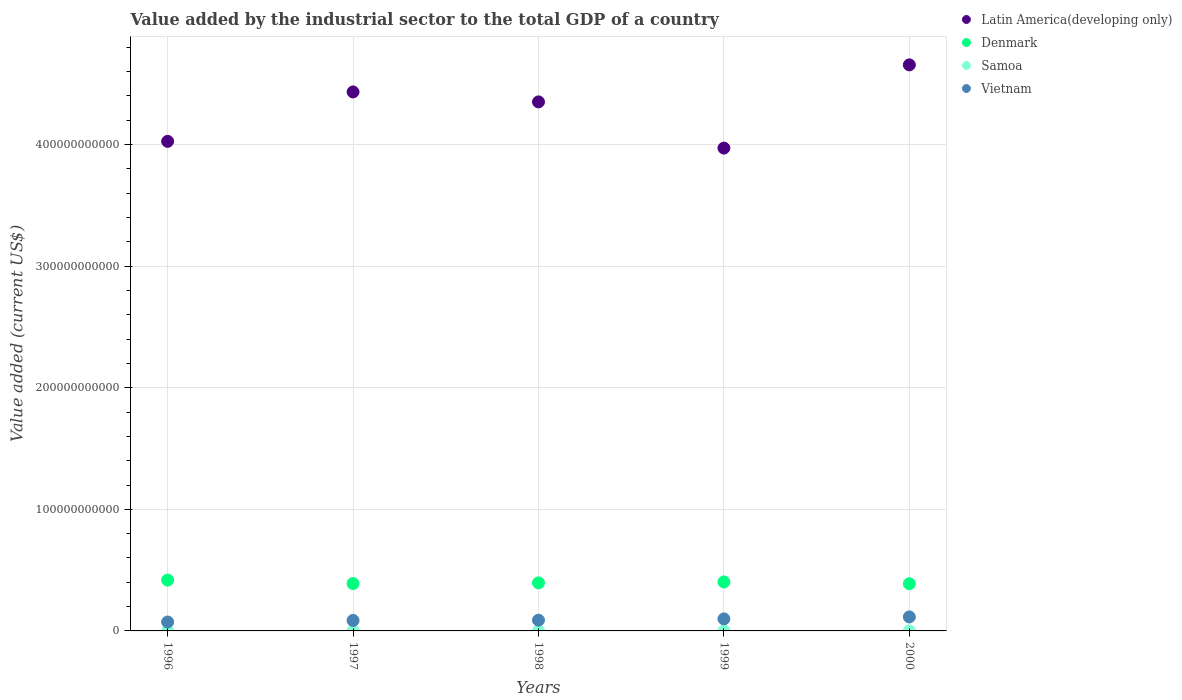What is the value added by the industrial sector to the total GDP in Latin America(developing only) in 1996?
Offer a very short reply. 4.03e+11. Across all years, what is the maximum value added by the industrial sector to the total GDP in Denmark?
Ensure brevity in your answer.  4.18e+1. Across all years, what is the minimum value added by the industrial sector to the total GDP in Samoa?
Keep it short and to the point. 6.00e+07. In which year was the value added by the industrial sector to the total GDP in Denmark minimum?
Keep it short and to the point. 2000. What is the total value added by the industrial sector to the total GDP in Denmark in the graph?
Your answer should be very brief. 1.99e+11. What is the difference between the value added by the industrial sector to the total GDP in Vietnam in 1996 and that in 1999?
Make the answer very short. -2.56e+09. What is the difference between the value added by the industrial sector to the total GDP in Samoa in 1997 and the value added by the industrial sector to the total GDP in Latin America(developing only) in 1999?
Keep it short and to the point. -3.97e+11. What is the average value added by the industrial sector to the total GDP in Denmark per year?
Provide a succinct answer. 3.99e+1. In the year 2000, what is the difference between the value added by the industrial sector to the total GDP in Vietnam and value added by the industrial sector to the total GDP in Samoa?
Provide a short and direct response. 1.14e+1. What is the ratio of the value added by the industrial sector to the total GDP in Vietnam in 1996 to that in 1998?
Keep it short and to the point. 0.83. Is the value added by the industrial sector to the total GDP in Samoa in 1999 less than that in 2000?
Keep it short and to the point. Yes. Is the difference between the value added by the industrial sector to the total GDP in Vietnam in 1998 and 1999 greater than the difference between the value added by the industrial sector to the total GDP in Samoa in 1998 and 1999?
Your response must be concise. No. What is the difference between the highest and the second highest value added by the industrial sector to the total GDP in Latin America(developing only)?
Offer a very short reply. 2.22e+1. What is the difference between the highest and the lowest value added by the industrial sector to the total GDP in Denmark?
Provide a short and direct response. 2.99e+09. In how many years, is the value added by the industrial sector to the total GDP in Vietnam greater than the average value added by the industrial sector to the total GDP in Vietnam taken over all years?
Your answer should be very brief. 2. Is the value added by the industrial sector to the total GDP in Vietnam strictly greater than the value added by the industrial sector to the total GDP in Latin America(developing only) over the years?
Offer a terse response. No. How many years are there in the graph?
Your answer should be very brief. 5. What is the difference between two consecutive major ticks on the Y-axis?
Ensure brevity in your answer.  1.00e+11. Does the graph contain grids?
Ensure brevity in your answer.  Yes. What is the title of the graph?
Give a very brief answer. Value added by the industrial sector to the total GDP of a country. What is the label or title of the X-axis?
Keep it short and to the point. Years. What is the label or title of the Y-axis?
Offer a very short reply. Value added (current US$). What is the Value added (current US$) of Latin America(developing only) in 1996?
Give a very brief answer. 4.03e+11. What is the Value added (current US$) in Denmark in 1996?
Provide a succinct answer. 4.18e+1. What is the Value added (current US$) of Samoa in 1996?
Make the answer very short. 6.72e+07. What is the Value added (current US$) of Vietnam in 1996?
Keep it short and to the point. 7.33e+09. What is the Value added (current US$) in Latin America(developing only) in 1997?
Provide a succinct answer. 4.43e+11. What is the Value added (current US$) of Denmark in 1997?
Your answer should be very brief. 3.90e+1. What is the Value added (current US$) in Samoa in 1997?
Provide a short and direct response. 7.11e+07. What is the Value added (current US$) of Vietnam in 1997?
Your answer should be very brief. 8.61e+09. What is the Value added (current US$) in Latin America(developing only) in 1998?
Make the answer very short. 4.35e+11. What is the Value added (current US$) in Denmark in 1998?
Give a very brief answer. 3.95e+1. What is the Value added (current US$) in Samoa in 1998?
Offer a very short reply. 6.24e+07. What is the Value added (current US$) of Vietnam in 1998?
Offer a very short reply. 8.84e+09. What is the Value added (current US$) in Latin America(developing only) in 1999?
Offer a very short reply. 3.97e+11. What is the Value added (current US$) in Denmark in 1999?
Provide a short and direct response. 4.03e+1. What is the Value added (current US$) of Samoa in 1999?
Provide a short and direct response. 6.00e+07. What is the Value added (current US$) of Vietnam in 1999?
Ensure brevity in your answer.  9.89e+09. What is the Value added (current US$) of Latin America(developing only) in 2000?
Your answer should be compact. 4.66e+11. What is the Value added (current US$) of Denmark in 2000?
Your answer should be compact. 3.88e+1. What is the Value added (current US$) of Samoa in 2000?
Your answer should be compact. 6.65e+07. What is the Value added (current US$) in Vietnam in 2000?
Provide a short and direct response. 1.15e+1. Across all years, what is the maximum Value added (current US$) in Latin America(developing only)?
Provide a succinct answer. 4.66e+11. Across all years, what is the maximum Value added (current US$) in Denmark?
Give a very brief answer. 4.18e+1. Across all years, what is the maximum Value added (current US$) in Samoa?
Your response must be concise. 7.11e+07. Across all years, what is the maximum Value added (current US$) of Vietnam?
Provide a short and direct response. 1.15e+1. Across all years, what is the minimum Value added (current US$) in Latin America(developing only)?
Keep it short and to the point. 3.97e+11. Across all years, what is the minimum Value added (current US$) of Denmark?
Offer a terse response. 3.88e+1. Across all years, what is the minimum Value added (current US$) in Samoa?
Provide a succinct answer. 6.00e+07. Across all years, what is the minimum Value added (current US$) in Vietnam?
Provide a succinct answer. 7.33e+09. What is the total Value added (current US$) in Latin America(developing only) in the graph?
Provide a short and direct response. 2.14e+12. What is the total Value added (current US$) of Denmark in the graph?
Provide a succinct answer. 1.99e+11. What is the total Value added (current US$) in Samoa in the graph?
Give a very brief answer. 3.27e+08. What is the total Value added (current US$) in Vietnam in the graph?
Your answer should be very brief. 4.62e+1. What is the difference between the Value added (current US$) in Latin America(developing only) in 1996 and that in 1997?
Offer a very short reply. -4.07e+1. What is the difference between the Value added (current US$) of Denmark in 1996 and that in 1997?
Keep it short and to the point. 2.86e+09. What is the difference between the Value added (current US$) of Samoa in 1996 and that in 1997?
Ensure brevity in your answer.  -3.86e+06. What is the difference between the Value added (current US$) of Vietnam in 1996 and that in 1997?
Your answer should be compact. -1.28e+09. What is the difference between the Value added (current US$) in Latin America(developing only) in 1996 and that in 1998?
Ensure brevity in your answer.  -3.24e+1. What is the difference between the Value added (current US$) in Denmark in 1996 and that in 1998?
Provide a short and direct response. 2.30e+09. What is the difference between the Value added (current US$) of Samoa in 1996 and that in 1998?
Your response must be concise. 4.77e+06. What is the difference between the Value added (current US$) of Vietnam in 1996 and that in 1998?
Offer a terse response. -1.51e+09. What is the difference between the Value added (current US$) in Latin America(developing only) in 1996 and that in 1999?
Your answer should be compact. 5.54e+09. What is the difference between the Value added (current US$) of Denmark in 1996 and that in 1999?
Give a very brief answer. 1.53e+09. What is the difference between the Value added (current US$) in Samoa in 1996 and that in 1999?
Offer a terse response. 7.21e+06. What is the difference between the Value added (current US$) of Vietnam in 1996 and that in 1999?
Provide a succinct answer. -2.56e+09. What is the difference between the Value added (current US$) of Latin America(developing only) in 1996 and that in 2000?
Your answer should be compact. -6.29e+1. What is the difference between the Value added (current US$) in Denmark in 1996 and that in 2000?
Your response must be concise. 2.99e+09. What is the difference between the Value added (current US$) in Samoa in 1996 and that in 2000?
Make the answer very short. 7.45e+05. What is the difference between the Value added (current US$) in Vietnam in 1996 and that in 2000?
Ensure brevity in your answer.  -4.17e+09. What is the difference between the Value added (current US$) of Latin America(developing only) in 1997 and that in 1998?
Your answer should be very brief. 8.21e+09. What is the difference between the Value added (current US$) in Denmark in 1997 and that in 1998?
Give a very brief answer. -5.51e+08. What is the difference between the Value added (current US$) in Samoa in 1997 and that in 1998?
Offer a terse response. 8.63e+06. What is the difference between the Value added (current US$) in Vietnam in 1997 and that in 1998?
Offer a very short reply. -2.31e+08. What is the difference between the Value added (current US$) in Latin America(developing only) in 1997 and that in 1999?
Provide a short and direct response. 4.62e+1. What is the difference between the Value added (current US$) in Denmark in 1997 and that in 1999?
Offer a terse response. -1.32e+09. What is the difference between the Value added (current US$) in Samoa in 1997 and that in 1999?
Make the answer very short. 1.11e+07. What is the difference between the Value added (current US$) in Vietnam in 1997 and that in 1999?
Make the answer very short. -1.28e+09. What is the difference between the Value added (current US$) of Latin America(developing only) in 1997 and that in 2000?
Give a very brief answer. -2.22e+1. What is the difference between the Value added (current US$) in Denmark in 1997 and that in 2000?
Your answer should be compact. 1.36e+08. What is the difference between the Value added (current US$) in Samoa in 1997 and that in 2000?
Offer a very short reply. 4.61e+06. What is the difference between the Value added (current US$) of Vietnam in 1997 and that in 2000?
Provide a succinct answer. -2.89e+09. What is the difference between the Value added (current US$) of Latin America(developing only) in 1998 and that in 1999?
Provide a succinct answer. 3.80e+1. What is the difference between the Value added (current US$) of Denmark in 1998 and that in 1999?
Your response must be concise. -7.73e+08. What is the difference between the Value added (current US$) in Samoa in 1998 and that in 1999?
Keep it short and to the point. 2.44e+06. What is the difference between the Value added (current US$) in Vietnam in 1998 and that in 1999?
Give a very brief answer. -1.05e+09. What is the difference between the Value added (current US$) of Latin America(developing only) in 1998 and that in 2000?
Give a very brief answer. -3.05e+1. What is the difference between the Value added (current US$) of Denmark in 1998 and that in 2000?
Offer a terse response. 6.87e+08. What is the difference between the Value added (current US$) in Samoa in 1998 and that in 2000?
Make the answer very short. -4.02e+06. What is the difference between the Value added (current US$) in Vietnam in 1998 and that in 2000?
Your response must be concise. -2.66e+09. What is the difference between the Value added (current US$) in Latin America(developing only) in 1999 and that in 2000?
Your answer should be very brief. -6.84e+1. What is the difference between the Value added (current US$) in Denmark in 1999 and that in 2000?
Ensure brevity in your answer.  1.46e+09. What is the difference between the Value added (current US$) of Samoa in 1999 and that in 2000?
Provide a succinct answer. -6.47e+06. What is the difference between the Value added (current US$) of Vietnam in 1999 and that in 2000?
Offer a terse response. -1.61e+09. What is the difference between the Value added (current US$) of Latin America(developing only) in 1996 and the Value added (current US$) of Denmark in 1997?
Provide a short and direct response. 3.64e+11. What is the difference between the Value added (current US$) in Latin America(developing only) in 1996 and the Value added (current US$) in Samoa in 1997?
Your response must be concise. 4.03e+11. What is the difference between the Value added (current US$) in Latin America(developing only) in 1996 and the Value added (current US$) in Vietnam in 1997?
Offer a very short reply. 3.94e+11. What is the difference between the Value added (current US$) of Denmark in 1996 and the Value added (current US$) of Samoa in 1997?
Your response must be concise. 4.17e+1. What is the difference between the Value added (current US$) in Denmark in 1996 and the Value added (current US$) in Vietnam in 1997?
Your response must be concise. 3.32e+1. What is the difference between the Value added (current US$) of Samoa in 1996 and the Value added (current US$) of Vietnam in 1997?
Give a very brief answer. -8.54e+09. What is the difference between the Value added (current US$) in Latin America(developing only) in 1996 and the Value added (current US$) in Denmark in 1998?
Offer a very short reply. 3.63e+11. What is the difference between the Value added (current US$) of Latin America(developing only) in 1996 and the Value added (current US$) of Samoa in 1998?
Offer a terse response. 4.03e+11. What is the difference between the Value added (current US$) in Latin America(developing only) in 1996 and the Value added (current US$) in Vietnam in 1998?
Offer a very short reply. 3.94e+11. What is the difference between the Value added (current US$) of Denmark in 1996 and the Value added (current US$) of Samoa in 1998?
Your answer should be very brief. 4.18e+1. What is the difference between the Value added (current US$) in Denmark in 1996 and the Value added (current US$) in Vietnam in 1998?
Make the answer very short. 3.30e+1. What is the difference between the Value added (current US$) of Samoa in 1996 and the Value added (current US$) of Vietnam in 1998?
Keep it short and to the point. -8.77e+09. What is the difference between the Value added (current US$) of Latin America(developing only) in 1996 and the Value added (current US$) of Denmark in 1999?
Offer a terse response. 3.62e+11. What is the difference between the Value added (current US$) in Latin America(developing only) in 1996 and the Value added (current US$) in Samoa in 1999?
Give a very brief answer. 4.03e+11. What is the difference between the Value added (current US$) of Latin America(developing only) in 1996 and the Value added (current US$) of Vietnam in 1999?
Your answer should be very brief. 3.93e+11. What is the difference between the Value added (current US$) of Denmark in 1996 and the Value added (current US$) of Samoa in 1999?
Provide a short and direct response. 4.18e+1. What is the difference between the Value added (current US$) in Denmark in 1996 and the Value added (current US$) in Vietnam in 1999?
Offer a terse response. 3.19e+1. What is the difference between the Value added (current US$) of Samoa in 1996 and the Value added (current US$) of Vietnam in 1999?
Your answer should be compact. -9.83e+09. What is the difference between the Value added (current US$) in Latin America(developing only) in 1996 and the Value added (current US$) in Denmark in 2000?
Your answer should be compact. 3.64e+11. What is the difference between the Value added (current US$) in Latin America(developing only) in 1996 and the Value added (current US$) in Samoa in 2000?
Your answer should be compact. 4.03e+11. What is the difference between the Value added (current US$) in Latin America(developing only) in 1996 and the Value added (current US$) in Vietnam in 2000?
Offer a terse response. 3.91e+11. What is the difference between the Value added (current US$) in Denmark in 1996 and the Value added (current US$) in Samoa in 2000?
Offer a very short reply. 4.18e+1. What is the difference between the Value added (current US$) of Denmark in 1996 and the Value added (current US$) of Vietnam in 2000?
Make the answer very short. 3.03e+1. What is the difference between the Value added (current US$) of Samoa in 1996 and the Value added (current US$) of Vietnam in 2000?
Keep it short and to the point. -1.14e+1. What is the difference between the Value added (current US$) of Latin America(developing only) in 1997 and the Value added (current US$) of Denmark in 1998?
Offer a very short reply. 4.04e+11. What is the difference between the Value added (current US$) in Latin America(developing only) in 1997 and the Value added (current US$) in Samoa in 1998?
Your response must be concise. 4.43e+11. What is the difference between the Value added (current US$) in Latin America(developing only) in 1997 and the Value added (current US$) in Vietnam in 1998?
Ensure brevity in your answer.  4.34e+11. What is the difference between the Value added (current US$) in Denmark in 1997 and the Value added (current US$) in Samoa in 1998?
Offer a terse response. 3.89e+1. What is the difference between the Value added (current US$) in Denmark in 1997 and the Value added (current US$) in Vietnam in 1998?
Make the answer very short. 3.01e+1. What is the difference between the Value added (current US$) of Samoa in 1997 and the Value added (current US$) of Vietnam in 1998?
Give a very brief answer. -8.77e+09. What is the difference between the Value added (current US$) of Latin America(developing only) in 1997 and the Value added (current US$) of Denmark in 1999?
Give a very brief answer. 4.03e+11. What is the difference between the Value added (current US$) of Latin America(developing only) in 1997 and the Value added (current US$) of Samoa in 1999?
Keep it short and to the point. 4.43e+11. What is the difference between the Value added (current US$) in Latin America(developing only) in 1997 and the Value added (current US$) in Vietnam in 1999?
Your response must be concise. 4.33e+11. What is the difference between the Value added (current US$) in Denmark in 1997 and the Value added (current US$) in Samoa in 1999?
Make the answer very short. 3.89e+1. What is the difference between the Value added (current US$) in Denmark in 1997 and the Value added (current US$) in Vietnam in 1999?
Your answer should be compact. 2.91e+1. What is the difference between the Value added (current US$) of Samoa in 1997 and the Value added (current US$) of Vietnam in 1999?
Ensure brevity in your answer.  -9.82e+09. What is the difference between the Value added (current US$) of Latin America(developing only) in 1997 and the Value added (current US$) of Denmark in 2000?
Offer a very short reply. 4.04e+11. What is the difference between the Value added (current US$) in Latin America(developing only) in 1997 and the Value added (current US$) in Samoa in 2000?
Provide a succinct answer. 4.43e+11. What is the difference between the Value added (current US$) in Latin America(developing only) in 1997 and the Value added (current US$) in Vietnam in 2000?
Ensure brevity in your answer.  4.32e+11. What is the difference between the Value added (current US$) in Denmark in 1997 and the Value added (current US$) in Samoa in 2000?
Offer a very short reply. 3.89e+1. What is the difference between the Value added (current US$) in Denmark in 1997 and the Value added (current US$) in Vietnam in 2000?
Your response must be concise. 2.75e+1. What is the difference between the Value added (current US$) of Samoa in 1997 and the Value added (current US$) of Vietnam in 2000?
Your response must be concise. -1.14e+1. What is the difference between the Value added (current US$) in Latin America(developing only) in 1998 and the Value added (current US$) in Denmark in 1999?
Offer a terse response. 3.95e+11. What is the difference between the Value added (current US$) of Latin America(developing only) in 1998 and the Value added (current US$) of Samoa in 1999?
Your answer should be very brief. 4.35e+11. What is the difference between the Value added (current US$) of Latin America(developing only) in 1998 and the Value added (current US$) of Vietnam in 1999?
Offer a terse response. 4.25e+11. What is the difference between the Value added (current US$) of Denmark in 1998 and the Value added (current US$) of Samoa in 1999?
Offer a terse response. 3.95e+1. What is the difference between the Value added (current US$) in Denmark in 1998 and the Value added (current US$) in Vietnam in 1999?
Offer a very short reply. 2.96e+1. What is the difference between the Value added (current US$) of Samoa in 1998 and the Value added (current US$) of Vietnam in 1999?
Your response must be concise. -9.83e+09. What is the difference between the Value added (current US$) in Latin America(developing only) in 1998 and the Value added (current US$) in Denmark in 2000?
Keep it short and to the point. 3.96e+11. What is the difference between the Value added (current US$) in Latin America(developing only) in 1998 and the Value added (current US$) in Samoa in 2000?
Ensure brevity in your answer.  4.35e+11. What is the difference between the Value added (current US$) in Latin America(developing only) in 1998 and the Value added (current US$) in Vietnam in 2000?
Your response must be concise. 4.24e+11. What is the difference between the Value added (current US$) in Denmark in 1998 and the Value added (current US$) in Samoa in 2000?
Provide a short and direct response. 3.94e+1. What is the difference between the Value added (current US$) in Denmark in 1998 and the Value added (current US$) in Vietnam in 2000?
Provide a succinct answer. 2.80e+1. What is the difference between the Value added (current US$) in Samoa in 1998 and the Value added (current US$) in Vietnam in 2000?
Provide a succinct answer. -1.14e+1. What is the difference between the Value added (current US$) of Latin America(developing only) in 1999 and the Value added (current US$) of Denmark in 2000?
Your response must be concise. 3.58e+11. What is the difference between the Value added (current US$) of Latin America(developing only) in 1999 and the Value added (current US$) of Samoa in 2000?
Make the answer very short. 3.97e+11. What is the difference between the Value added (current US$) in Latin America(developing only) in 1999 and the Value added (current US$) in Vietnam in 2000?
Keep it short and to the point. 3.86e+11. What is the difference between the Value added (current US$) in Denmark in 1999 and the Value added (current US$) in Samoa in 2000?
Your response must be concise. 4.02e+1. What is the difference between the Value added (current US$) of Denmark in 1999 and the Value added (current US$) of Vietnam in 2000?
Provide a succinct answer. 2.88e+1. What is the difference between the Value added (current US$) in Samoa in 1999 and the Value added (current US$) in Vietnam in 2000?
Give a very brief answer. -1.14e+1. What is the average Value added (current US$) in Latin America(developing only) per year?
Offer a very short reply. 4.29e+11. What is the average Value added (current US$) of Denmark per year?
Make the answer very short. 3.99e+1. What is the average Value added (current US$) in Samoa per year?
Give a very brief answer. 6.54e+07. What is the average Value added (current US$) of Vietnam per year?
Keep it short and to the point. 9.24e+09. In the year 1996, what is the difference between the Value added (current US$) in Latin America(developing only) and Value added (current US$) in Denmark?
Offer a terse response. 3.61e+11. In the year 1996, what is the difference between the Value added (current US$) in Latin America(developing only) and Value added (current US$) in Samoa?
Offer a terse response. 4.03e+11. In the year 1996, what is the difference between the Value added (current US$) in Latin America(developing only) and Value added (current US$) in Vietnam?
Keep it short and to the point. 3.95e+11. In the year 1996, what is the difference between the Value added (current US$) in Denmark and Value added (current US$) in Samoa?
Make the answer very short. 4.18e+1. In the year 1996, what is the difference between the Value added (current US$) in Denmark and Value added (current US$) in Vietnam?
Provide a succinct answer. 3.45e+1. In the year 1996, what is the difference between the Value added (current US$) in Samoa and Value added (current US$) in Vietnam?
Provide a succinct answer. -7.26e+09. In the year 1997, what is the difference between the Value added (current US$) in Latin America(developing only) and Value added (current US$) in Denmark?
Your response must be concise. 4.04e+11. In the year 1997, what is the difference between the Value added (current US$) in Latin America(developing only) and Value added (current US$) in Samoa?
Provide a short and direct response. 4.43e+11. In the year 1997, what is the difference between the Value added (current US$) of Latin America(developing only) and Value added (current US$) of Vietnam?
Offer a terse response. 4.35e+11. In the year 1997, what is the difference between the Value added (current US$) of Denmark and Value added (current US$) of Samoa?
Your answer should be compact. 3.89e+1. In the year 1997, what is the difference between the Value added (current US$) in Denmark and Value added (current US$) in Vietnam?
Your answer should be very brief. 3.04e+1. In the year 1997, what is the difference between the Value added (current US$) of Samoa and Value added (current US$) of Vietnam?
Make the answer very short. -8.54e+09. In the year 1998, what is the difference between the Value added (current US$) of Latin America(developing only) and Value added (current US$) of Denmark?
Provide a short and direct response. 3.96e+11. In the year 1998, what is the difference between the Value added (current US$) of Latin America(developing only) and Value added (current US$) of Samoa?
Your response must be concise. 4.35e+11. In the year 1998, what is the difference between the Value added (current US$) of Latin America(developing only) and Value added (current US$) of Vietnam?
Your answer should be compact. 4.26e+11. In the year 1998, what is the difference between the Value added (current US$) in Denmark and Value added (current US$) in Samoa?
Give a very brief answer. 3.95e+1. In the year 1998, what is the difference between the Value added (current US$) in Denmark and Value added (current US$) in Vietnam?
Your response must be concise. 3.07e+1. In the year 1998, what is the difference between the Value added (current US$) of Samoa and Value added (current US$) of Vietnam?
Make the answer very short. -8.78e+09. In the year 1999, what is the difference between the Value added (current US$) in Latin America(developing only) and Value added (current US$) in Denmark?
Provide a short and direct response. 3.57e+11. In the year 1999, what is the difference between the Value added (current US$) in Latin America(developing only) and Value added (current US$) in Samoa?
Ensure brevity in your answer.  3.97e+11. In the year 1999, what is the difference between the Value added (current US$) of Latin America(developing only) and Value added (current US$) of Vietnam?
Keep it short and to the point. 3.87e+11. In the year 1999, what is the difference between the Value added (current US$) in Denmark and Value added (current US$) in Samoa?
Offer a very short reply. 4.02e+1. In the year 1999, what is the difference between the Value added (current US$) of Denmark and Value added (current US$) of Vietnam?
Your answer should be very brief. 3.04e+1. In the year 1999, what is the difference between the Value added (current US$) in Samoa and Value added (current US$) in Vietnam?
Offer a very short reply. -9.83e+09. In the year 2000, what is the difference between the Value added (current US$) of Latin America(developing only) and Value added (current US$) of Denmark?
Your answer should be compact. 4.27e+11. In the year 2000, what is the difference between the Value added (current US$) in Latin America(developing only) and Value added (current US$) in Samoa?
Offer a very short reply. 4.65e+11. In the year 2000, what is the difference between the Value added (current US$) of Latin America(developing only) and Value added (current US$) of Vietnam?
Give a very brief answer. 4.54e+11. In the year 2000, what is the difference between the Value added (current US$) in Denmark and Value added (current US$) in Samoa?
Your answer should be compact. 3.88e+1. In the year 2000, what is the difference between the Value added (current US$) in Denmark and Value added (current US$) in Vietnam?
Ensure brevity in your answer.  2.73e+1. In the year 2000, what is the difference between the Value added (current US$) of Samoa and Value added (current US$) of Vietnam?
Offer a very short reply. -1.14e+1. What is the ratio of the Value added (current US$) of Latin America(developing only) in 1996 to that in 1997?
Provide a succinct answer. 0.91. What is the ratio of the Value added (current US$) of Denmark in 1996 to that in 1997?
Ensure brevity in your answer.  1.07. What is the ratio of the Value added (current US$) in Samoa in 1996 to that in 1997?
Your answer should be compact. 0.95. What is the ratio of the Value added (current US$) of Vietnam in 1996 to that in 1997?
Your response must be concise. 0.85. What is the ratio of the Value added (current US$) of Latin America(developing only) in 1996 to that in 1998?
Your answer should be compact. 0.93. What is the ratio of the Value added (current US$) of Denmark in 1996 to that in 1998?
Give a very brief answer. 1.06. What is the ratio of the Value added (current US$) in Samoa in 1996 to that in 1998?
Your answer should be very brief. 1.08. What is the ratio of the Value added (current US$) of Vietnam in 1996 to that in 1998?
Your response must be concise. 0.83. What is the ratio of the Value added (current US$) in Latin America(developing only) in 1996 to that in 1999?
Offer a terse response. 1.01. What is the ratio of the Value added (current US$) in Denmark in 1996 to that in 1999?
Offer a terse response. 1.04. What is the ratio of the Value added (current US$) of Samoa in 1996 to that in 1999?
Your answer should be compact. 1.12. What is the ratio of the Value added (current US$) in Vietnam in 1996 to that in 1999?
Your answer should be compact. 0.74. What is the ratio of the Value added (current US$) in Latin America(developing only) in 1996 to that in 2000?
Your answer should be compact. 0.86. What is the ratio of the Value added (current US$) in Denmark in 1996 to that in 2000?
Give a very brief answer. 1.08. What is the ratio of the Value added (current US$) of Samoa in 1996 to that in 2000?
Give a very brief answer. 1.01. What is the ratio of the Value added (current US$) in Vietnam in 1996 to that in 2000?
Offer a very short reply. 0.64. What is the ratio of the Value added (current US$) of Latin America(developing only) in 1997 to that in 1998?
Give a very brief answer. 1.02. What is the ratio of the Value added (current US$) in Samoa in 1997 to that in 1998?
Give a very brief answer. 1.14. What is the ratio of the Value added (current US$) in Vietnam in 1997 to that in 1998?
Offer a terse response. 0.97. What is the ratio of the Value added (current US$) in Latin America(developing only) in 1997 to that in 1999?
Ensure brevity in your answer.  1.12. What is the ratio of the Value added (current US$) of Denmark in 1997 to that in 1999?
Ensure brevity in your answer.  0.97. What is the ratio of the Value added (current US$) of Samoa in 1997 to that in 1999?
Your answer should be very brief. 1.18. What is the ratio of the Value added (current US$) in Vietnam in 1997 to that in 1999?
Offer a terse response. 0.87. What is the ratio of the Value added (current US$) in Latin America(developing only) in 1997 to that in 2000?
Keep it short and to the point. 0.95. What is the ratio of the Value added (current US$) in Samoa in 1997 to that in 2000?
Offer a terse response. 1.07. What is the ratio of the Value added (current US$) of Vietnam in 1997 to that in 2000?
Provide a succinct answer. 0.75. What is the ratio of the Value added (current US$) of Latin America(developing only) in 1998 to that in 1999?
Your response must be concise. 1.1. What is the ratio of the Value added (current US$) in Denmark in 1998 to that in 1999?
Your answer should be very brief. 0.98. What is the ratio of the Value added (current US$) in Samoa in 1998 to that in 1999?
Provide a short and direct response. 1.04. What is the ratio of the Value added (current US$) of Vietnam in 1998 to that in 1999?
Give a very brief answer. 0.89. What is the ratio of the Value added (current US$) of Latin America(developing only) in 1998 to that in 2000?
Offer a terse response. 0.93. What is the ratio of the Value added (current US$) in Denmark in 1998 to that in 2000?
Keep it short and to the point. 1.02. What is the ratio of the Value added (current US$) in Samoa in 1998 to that in 2000?
Give a very brief answer. 0.94. What is the ratio of the Value added (current US$) of Vietnam in 1998 to that in 2000?
Your answer should be very brief. 0.77. What is the ratio of the Value added (current US$) in Latin America(developing only) in 1999 to that in 2000?
Offer a terse response. 0.85. What is the ratio of the Value added (current US$) in Denmark in 1999 to that in 2000?
Offer a terse response. 1.04. What is the ratio of the Value added (current US$) of Samoa in 1999 to that in 2000?
Ensure brevity in your answer.  0.9. What is the ratio of the Value added (current US$) in Vietnam in 1999 to that in 2000?
Offer a terse response. 0.86. What is the difference between the highest and the second highest Value added (current US$) of Latin America(developing only)?
Keep it short and to the point. 2.22e+1. What is the difference between the highest and the second highest Value added (current US$) of Denmark?
Provide a short and direct response. 1.53e+09. What is the difference between the highest and the second highest Value added (current US$) of Samoa?
Make the answer very short. 3.86e+06. What is the difference between the highest and the second highest Value added (current US$) of Vietnam?
Your answer should be very brief. 1.61e+09. What is the difference between the highest and the lowest Value added (current US$) of Latin America(developing only)?
Ensure brevity in your answer.  6.84e+1. What is the difference between the highest and the lowest Value added (current US$) of Denmark?
Your answer should be very brief. 2.99e+09. What is the difference between the highest and the lowest Value added (current US$) of Samoa?
Offer a very short reply. 1.11e+07. What is the difference between the highest and the lowest Value added (current US$) of Vietnam?
Give a very brief answer. 4.17e+09. 